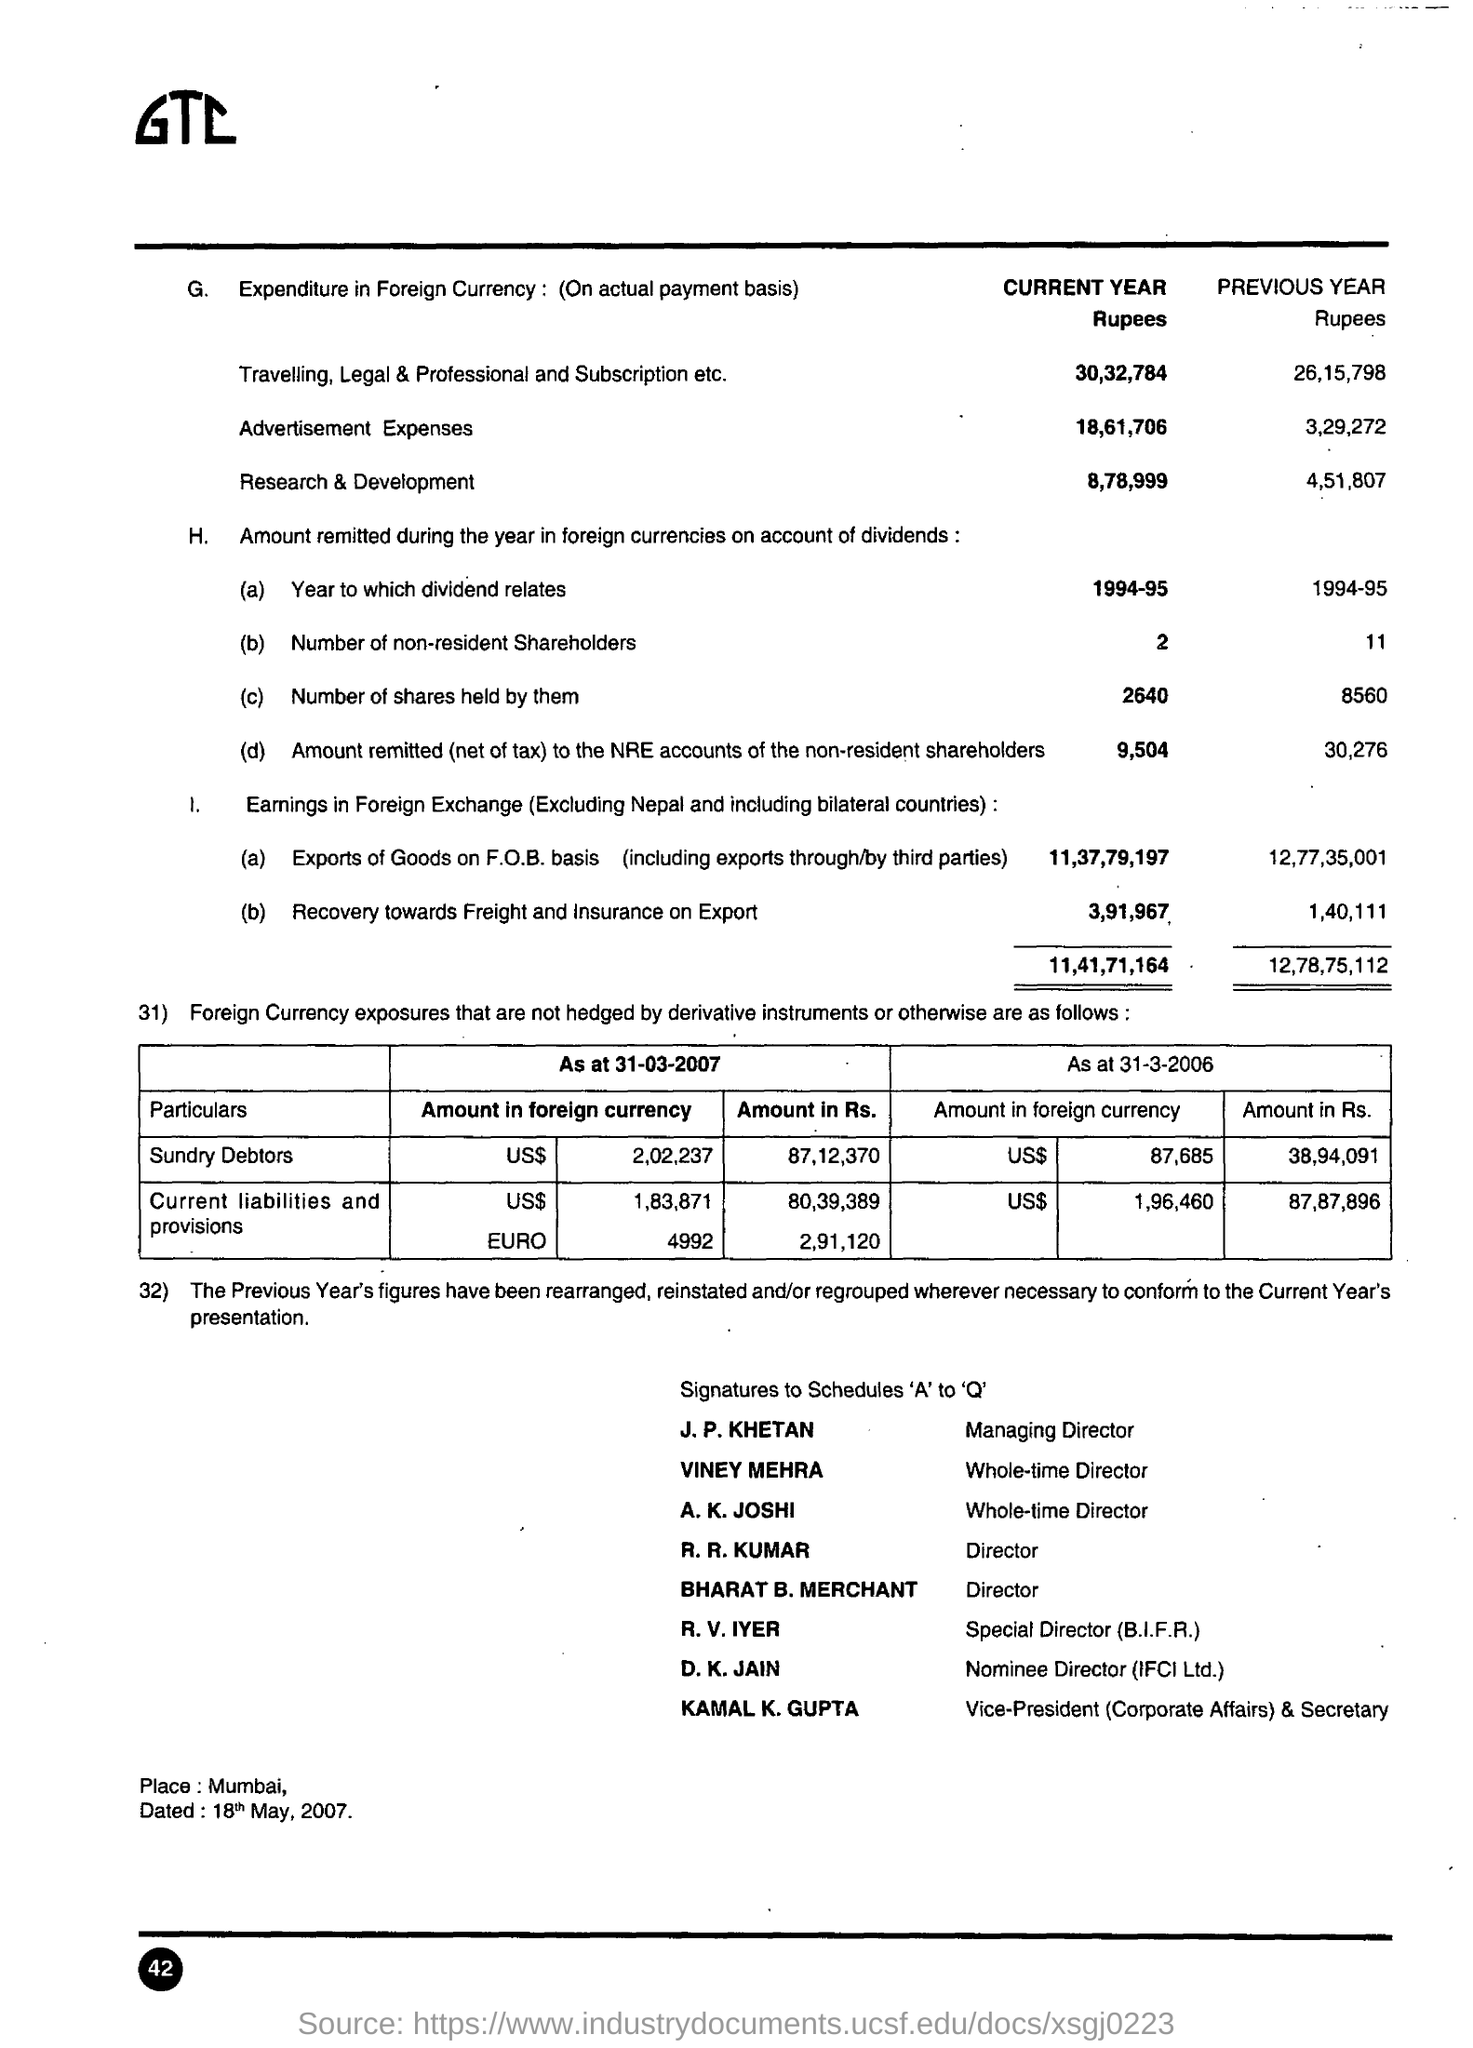Mention a couple of crucial points in this snapshot. The individual named R. R. Kumar holds the designation of Director. The date mentioned in the bottom of the document is 18th May, 2007. The amount allocated for research and development in the current year is 8,78,999. The person referred to as "Special Director r. v. iyer" is unknown. The managing director is J.P. Khetan. 